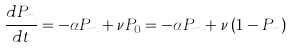Convert formula to latex. <formula><loc_0><loc_0><loc_500><loc_500>\frac { d P _ { m } } { d t } = - \alpha P _ { m } + \nu P _ { 0 } = - \alpha P _ { m } + \nu \left ( 1 - P _ { m } \right )</formula> 